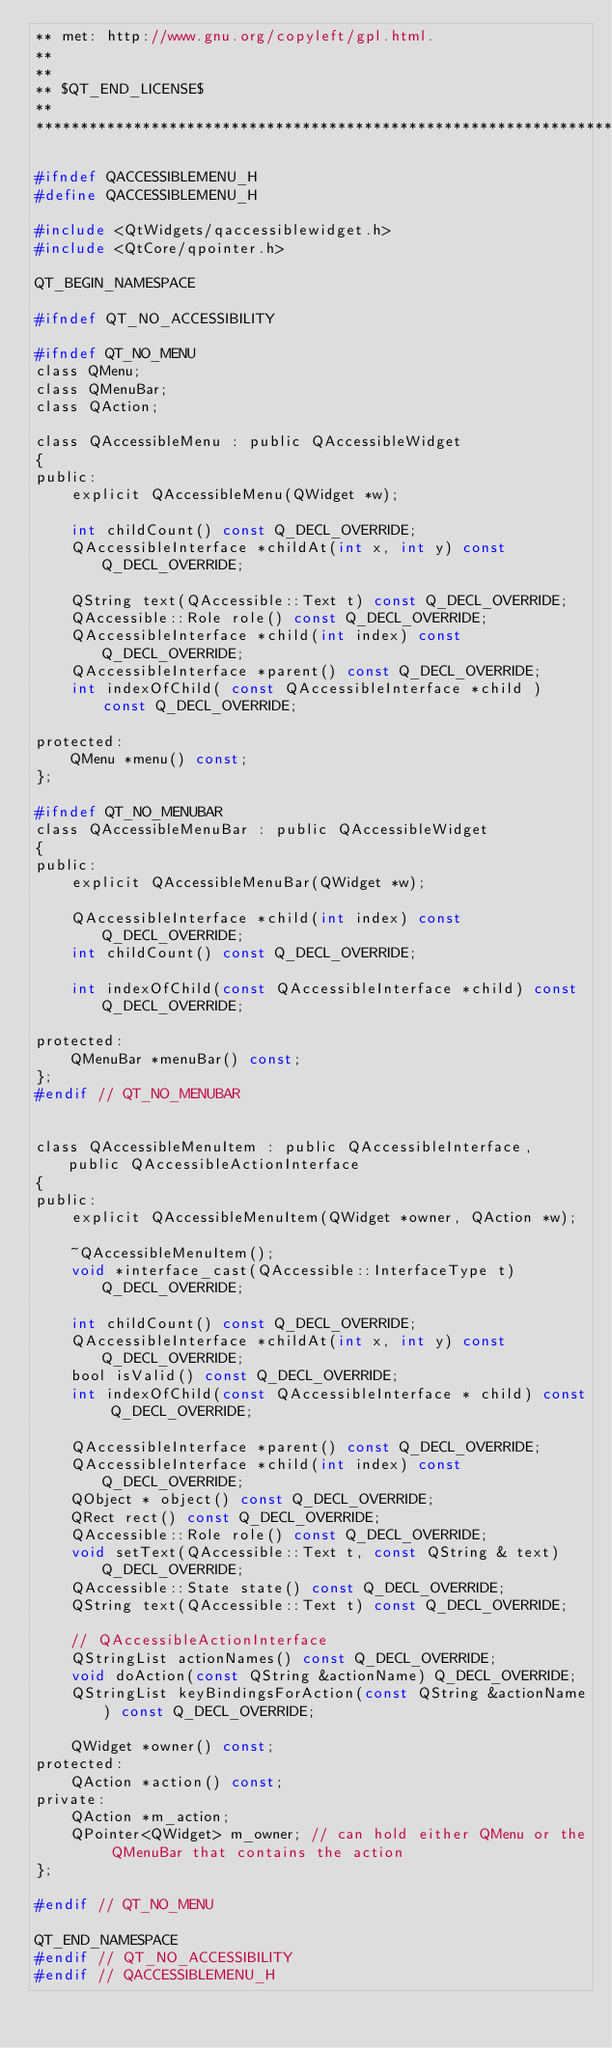<code> <loc_0><loc_0><loc_500><loc_500><_C_>** met: http://www.gnu.org/copyleft/gpl.html.
**
**
** $QT_END_LICENSE$
**
****************************************************************************/

#ifndef QACCESSIBLEMENU_H
#define QACCESSIBLEMENU_H

#include <QtWidgets/qaccessiblewidget.h>
#include <QtCore/qpointer.h>

QT_BEGIN_NAMESPACE

#ifndef QT_NO_ACCESSIBILITY

#ifndef QT_NO_MENU
class QMenu;
class QMenuBar;
class QAction;

class QAccessibleMenu : public QAccessibleWidget
{
public:
    explicit QAccessibleMenu(QWidget *w);

    int childCount() const Q_DECL_OVERRIDE;
    QAccessibleInterface *childAt(int x, int y) const Q_DECL_OVERRIDE;

    QString text(QAccessible::Text t) const Q_DECL_OVERRIDE;
    QAccessible::Role role() const Q_DECL_OVERRIDE;
    QAccessibleInterface *child(int index) const Q_DECL_OVERRIDE;
    QAccessibleInterface *parent() const Q_DECL_OVERRIDE;
    int indexOfChild( const QAccessibleInterface *child ) const Q_DECL_OVERRIDE;

protected:
    QMenu *menu() const;
};

#ifndef QT_NO_MENUBAR
class QAccessibleMenuBar : public QAccessibleWidget
{
public:
    explicit QAccessibleMenuBar(QWidget *w);

    QAccessibleInterface *child(int index) const Q_DECL_OVERRIDE;
    int childCount() const Q_DECL_OVERRIDE;

    int indexOfChild(const QAccessibleInterface *child) const Q_DECL_OVERRIDE;

protected:
    QMenuBar *menuBar() const;
};
#endif // QT_NO_MENUBAR


class QAccessibleMenuItem : public QAccessibleInterface, public QAccessibleActionInterface
{
public:
    explicit QAccessibleMenuItem(QWidget *owner, QAction *w);

    ~QAccessibleMenuItem();
    void *interface_cast(QAccessible::InterfaceType t) Q_DECL_OVERRIDE;

    int childCount() const Q_DECL_OVERRIDE;
    QAccessibleInterface *childAt(int x, int y) const Q_DECL_OVERRIDE;
    bool isValid() const Q_DECL_OVERRIDE;
    int indexOfChild(const QAccessibleInterface * child) const Q_DECL_OVERRIDE;

    QAccessibleInterface *parent() const Q_DECL_OVERRIDE;
    QAccessibleInterface *child(int index) const Q_DECL_OVERRIDE;
    QObject * object() const Q_DECL_OVERRIDE;
    QRect rect() const Q_DECL_OVERRIDE;
    QAccessible::Role role() const Q_DECL_OVERRIDE;
    void setText(QAccessible::Text t, const QString & text) Q_DECL_OVERRIDE;
    QAccessible::State state() const Q_DECL_OVERRIDE;
    QString text(QAccessible::Text t) const Q_DECL_OVERRIDE;

    // QAccessibleActionInterface
    QStringList actionNames() const Q_DECL_OVERRIDE;
    void doAction(const QString &actionName) Q_DECL_OVERRIDE;
    QStringList keyBindingsForAction(const QString &actionName) const Q_DECL_OVERRIDE;

    QWidget *owner() const;
protected:
    QAction *action() const;
private:
    QAction *m_action;
    QPointer<QWidget> m_owner; // can hold either QMenu or the QMenuBar that contains the action
};

#endif // QT_NO_MENU

QT_END_NAMESPACE
#endif // QT_NO_ACCESSIBILITY
#endif // QACCESSIBLEMENU_H
</code> 